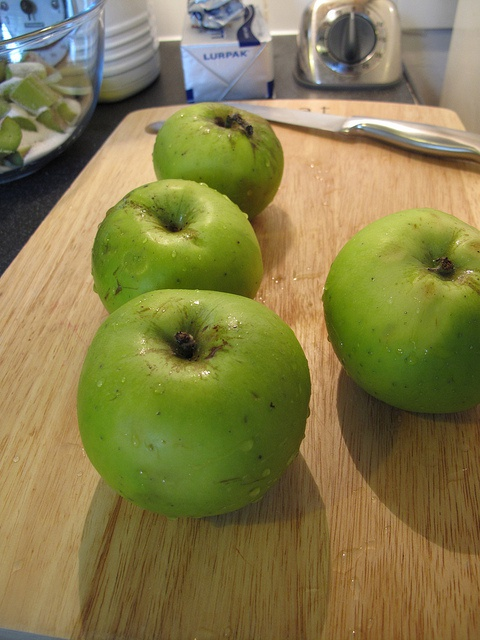Describe the objects in this image and their specific colors. I can see dining table in olive, gray, and tan tones, apple in gray, darkgreen, and olive tones, apple in gray, darkgreen, and olive tones, bowl in gray, olive, and darkgray tones, and apple in gray and olive tones in this image. 